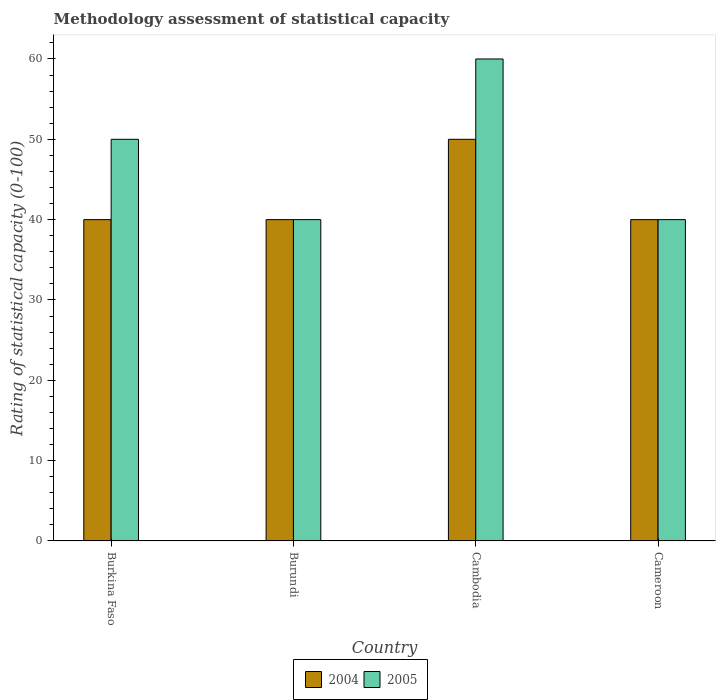How many different coloured bars are there?
Provide a succinct answer. 2. How many groups of bars are there?
Make the answer very short. 4. Are the number of bars on each tick of the X-axis equal?
Your answer should be very brief. Yes. What is the label of the 3rd group of bars from the left?
Offer a very short reply. Cambodia. In how many cases, is the number of bars for a given country not equal to the number of legend labels?
Give a very brief answer. 0. Across all countries, what is the maximum rating of statistical capacity in 2004?
Keep it short and to the point. 50. In which country was the rating of statistical capacity in 2005 maximum?
Ensure brevity in your answer.  Cambodia. In which country was the rating of statistical capacity in 2005 minimum?
Ensure brevity in your answer.  Burundi. What is the total rating of statistical capacity in 2004 in the graph?
Provide a short and direct response. 170. What is the difference between the rating of statistical capacity in 2004 in Burkina Faso and that in Cambodia?
Keep it short and to the point. -10. What is the average rating of statistical capacity in 2004 per country?
Offer a terse response. 42.5. What is the difference between the rating of statistical capacity of/in 2004 and rating of statistical capacity of/in 2005 in Cambodia?
Your answer should be compact. -10. In how many countries, is the rating of statistical capacity in 2005 greater than 52?
Offer a terse response. 1. What is the ratio of the rating of statistical capacity in 2005 in Burundi to that in Cameroon?
Your answer should be compact. 1. Is the rating of statistical capacity in 2005 in Burkina Faso less than that in Burundi?
Provide a short and direct response. No. Is the difference between the rating of statistical capacity in 2004 in Burundi and Cambodia greater than the difference between the rating of statistical capacity in 2005 in Burundi and Cambodia?
Offer a very short reply. Yes. What does the 1st bar from the left in Burkina Faso represents?
Your answer should be compact. 2004. How many bars are there?
Offer a terse response. 8. Are all the bars in the graph horizontal?
Offer a terse response. No. What is the difference between two consecutive major ticks on the Y-axis?
Your answer should be very brief. 10. Does the graph contain any zero values?
Ensure brevity in your answer.  No. Does the graph contain grids?
Provide a short and direct response. No. Where does the legend appear in the graph?
Your answer should be very brief. Bottom center. What is the title of the graph?
Give a very brief answer. Methodology assessment of statistical capacity. What is the label or title of the Y-axis?
Provide a short and direct response. Rating of statistical capacity (0-100). What is the Rating of statistical capacity (0-100) of 2004 in Burundi?
Offer a very short reply. 40. What is the Rating of statistical capacity (0-100) in 2004 in Cambodia?
Provide a succinct answer. 50. What is the Rating of statistical capacity (0-100) in 2005 in Cambodia?
Your answer should be very brief. 60. What is the Rating of statistical capacity (0-100) in 2004 in Cameroon?
Make the answer very short. 40. What is the Rating of statistical capacity (0-100) in 2005 in Cameroon?
Provide a short and direct response. 40. Across all countries, what is the maximum Rating of statistical capacity (0-100) of 2004?
Keep it short and to the point. 50. Across all countries, what is the minimum Rating of statistical capacity (0-100) of 2004?
Provide a succinct answer. 40. What is the total Rating of statistical capacity (0-100) in 2004 in the graph?
Your answer should be very brief. 170. What is the total Rating of statistical capacity (0-100) in 2005 in the graph?
Keep it short and to the point. 190. What is the difference between the Rating of statistical capacity (0-100) of 2004 in Burkina Faso and that in Burundi?
Give a very brief answer. 0. What is the difference between the Rating of statistical capacity (0-100) in 2005 in Burkina Faso and that in Burundi?
Your answer should be compact. 10. What is the difference between the Rating of statistical capacity (0-100) in 2004 in Burkina Faso and that in Cambodia?
Your answer should be compact. -10. What is the difference between the Rating of statistical capacity (0-100) in 2005 in Burkina Faso and that in Cambodia?
Offer a terse response. -10. What is the difference between the Rating of statistical capacity (0-100) in 2005 in Burundi and that in Cambodia?
Provide a short and direct response. -20. What is the difference between the Rating of statistical capacity (0-100) of 2004 in Burkina Faso and the Rating of statistical capacity (0-100) of 2005 in Burundi?
Your answer should be very brief. 0. What is the difference between the Rating of statistical capacity (0-100) in 2004 in Burkina Faso and the Rating of statistical capacity (0-100) in 2005 in Cambodia?
Ensure brevity in your answer.  -20. What is the difference between the Rating of statistical capacity (0-100) in 2004 in Burkina Faso and the Rating of statistical capacity (0-100) in 2005 in Cameroon?
Provide a succinct answer. 0. What is the difference between the Rating of statistical capacity (0-100) in 2004 in Burundi and the Rating of statistical capacity (0-100) in 2005 in Cameroon?
Keep it short and to the point. 0. What is the difference between the Rating of statistical capacity (0-100) in 2004 in Cambodia and the Rating of statistical capacity (0-100) in 2005 in Cameroon?
Your response must be concise. 10. What is the average Rating of statistical capacity (0-100) in 2004 per country?
Offer a very short reply. 42.5. What is the average Rating of statistical capacity (0-100) of 2005 per country?
Your answer should be very brief. 47.5. What is the difference between the Rating of statistical capacity (0-100) in 2004 and Rating of statistical capacity (0-100) in 2005 in Burkina Faso?
Offer a very short reply. -10. What is the difference between the Rating of statistical capacity (0-100) of 2004 and Rating of statistical capacity (0-100) of 2005 in Burundi?
Your answer should be compact. 0. What is the difference between the Rating of statistical capacity (0-100) of 2004 and Rating of statistical capacity (0-100) of 2005 in Cambodia?
Your response must be concise. -10. What is the difference between the Rating of statistical capacity (0-100) of 2004 and Rating of statistical capacity (0-100) of 2005 in Cameroon?
Ensure brevity in your answer.  0. What is the ratio of the Rating of statistical capacity (0-100) in 2004 in Burkina Faso to that in Burundi?
Offer a terse response. 1. What is the ratio of the Rating of statistical capacity (0-100) of 2004 in Burkina Faso to that in Cameroon?
Provide a succinct answer. 1. What is the ratio of the Rating of statistical capacity (0-100) in 2005 in Burkina Faso to that in Cameroon?
Make the answer very short. 1.25. What is the ratio of the Rating of statistical capacity (0-100) in 2004 in Burundi to that in Cambodia?
Provide a short and direct response. 0.8. What is the ratio of the Rating of statistical capacity (0-100) in 2005 in Burundi to that in Cambodia?
Offer a terse response. 0.67. What is the ratio of the Rating of statistical capacity (0-100) of 2004 in Burundi to that in Cameroon?
Your answer should be compact. 1. What is the ratio of the Rating of statistical capacity (0-100) of 2005 in Burundi to that in Cameroon?
Give a very brief answer. 1. What is the ratio of the Rating of statistical capacity (0-100) in 2004 in Cambodia to that in Cameroon?
Make the answer very short. 1.25. What is the ratio of the Rating of statistical capacity (0-100) in 2005 in Cambodia to that in Cameroon?
Your answer should be very brief. 1.5. What is the difference between the highest and the second highest Rating of statistical capacity (0-100) of 2005?
Keep it short and to the point. 10. What is the difference between the highest and the lowest Rating of statistical capacity (0-100) of 2004?
Make the answer very short. 10. 